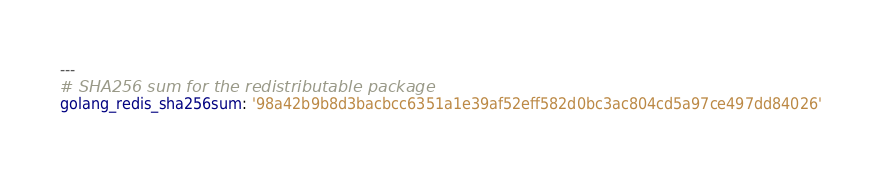<code> <loc_0><loc_0><loc_500><loc_500><_YAML_>---
# SHA256 sum for the redistributable package
golang_redis_sha256sum: '98a42b9b8d3bacbcc6351a1e39af52eff582d0bc3ac804cd5a97ce497dd84026'
</code> 